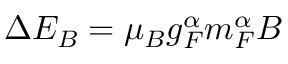<formula> <loc_0><loc_0><loc_500><loc_500>\Delta E _ { B } = \mu _ { B } g _ { F } ^ { \alpha } m _ { F } ^ { \alpha } B</formula> 